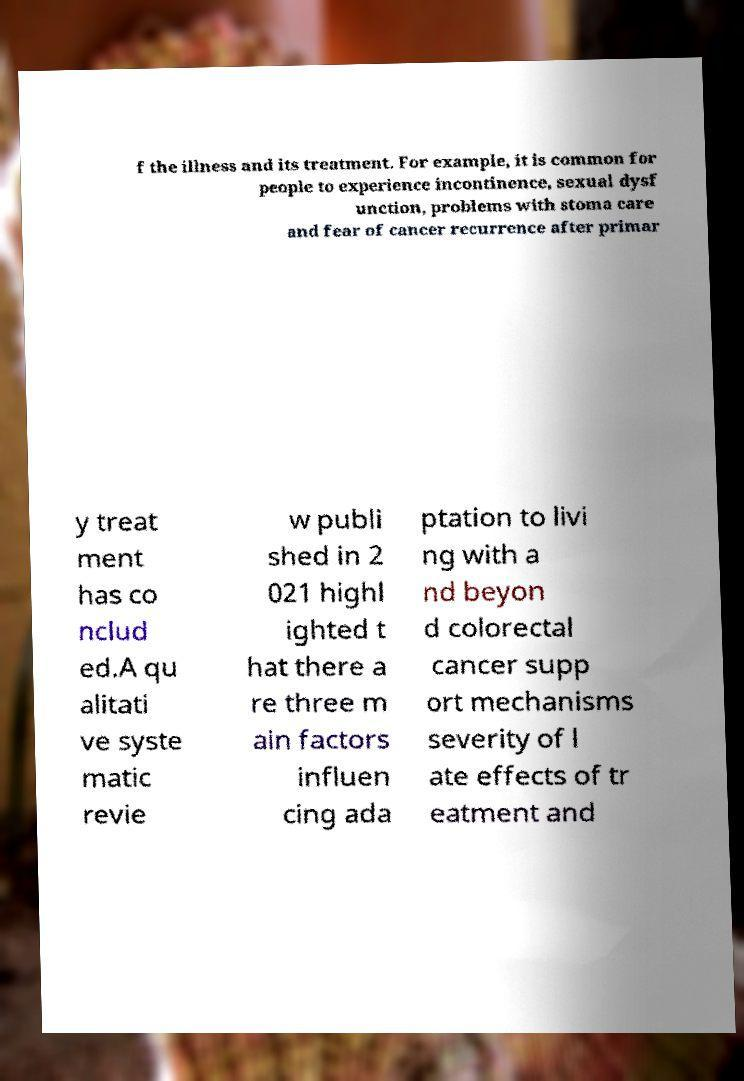What messages or text are displayed in this image? I need them in a readable, typed format. f the illness and its treatment. For example, it is common for people to experience incontinence, sexual dysf unction, problems with stoma care and fear of cancer recurrence after primar y treat ment has co nclud ed.A qu alitati ve syste matic revie w publi shed in 2 021 highl ighted t hat there a re three m ain factors influen cing ada ptation to livi ng with a nd beyon d colorectal cancer supp ort mechanisms severity of l ate effects of tr eatment and 